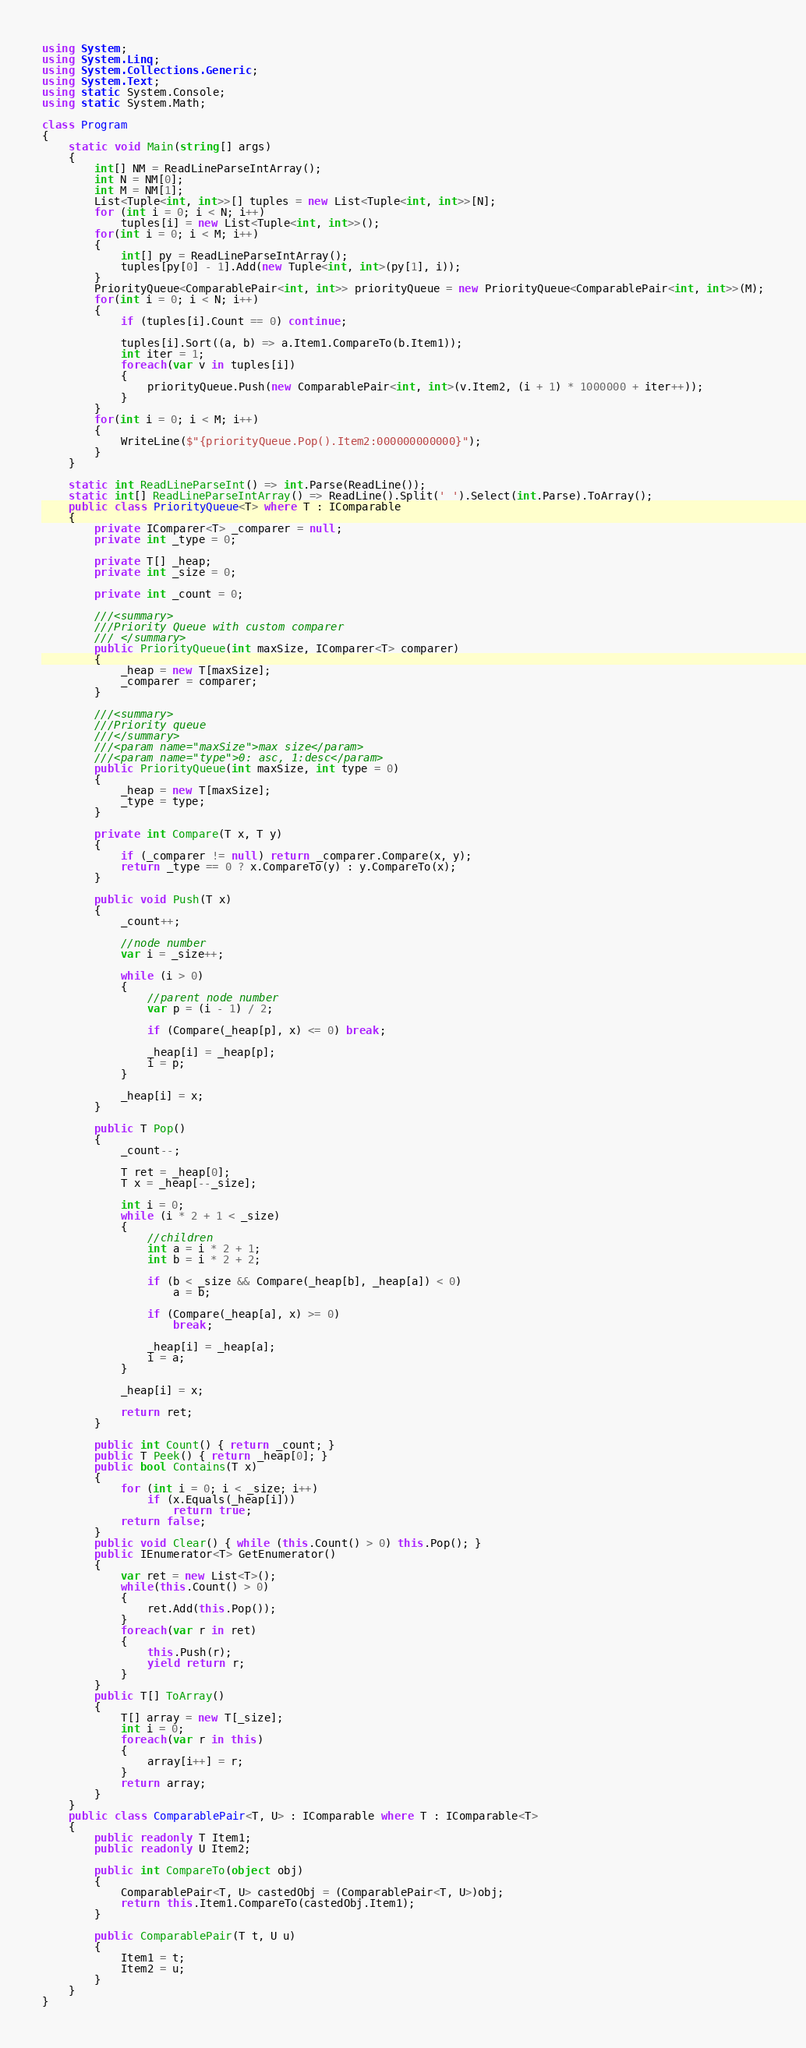<code> <loc_0><loc_0><loc_500><loc_500><_C#_>using System;
using System.Linq;
using System.Collections.Generic;
using System.Text;
using static System.Console;
using static System.Math;

class Program
{
    static void Main(string[] args)
    {
        int[] NM = ReadLineParseIntArray();
        int N = NM[0];
        int M = NM[1];
        List<Tuple<int, int>>[] tuples = new List<Tuple<int, int>>[N];
        for (int i = 0; i < N; i++)
            tuples[i] = new List<Tuple<int, int>>();
        for(int i = 0; i < M; i++)
        {
            int[] py = ReadLineParseIntArray();
            tuples[py[0] - 1].Add(new Tuple<int, int>(py[1], i));
        }
        PriorityQueue<ComparablePair<int, int>> priorityQueue = new PriorityQueue<ComparablePair<int, int>>(M);
        for(int i = 0; i < N; i++)
        {
            if (tuples[i].Count == 0) continue;

            tuples[i].Sort((a, b) => a.Item1.CompareTo(b.Item1));
            int iter = 1;
            foreach(var v in tuples[i])
            {
                priorityQueue.Push(new ComparablePair<int, int>(v.Item2, (i + 1) * 1000000 + iter++));
            }
        }
        for(int i = 0; i < M; i++)
        {
            WriteLine($"{priorityQueue.Pop().Item2:000000000000}");
        }
    }

    static int ReadLineParseInt() => int.Parse(ReadLine());
    static int[] ReadLineParseIntArray() => ReadLine().Split(' ').Select(int.Parse).ToArray();
    public class PriorityQueue<T> where T : IComparable
    {
        private IComparer<T> _comparer = null;
        private int _type = 0;

        private T[] _heap;
        private int _size = 0;

        private int _count = 0;

        ///<summary>
        ///Priority Queue with custom comparer
        /// </summary>
        public PriorityQueue(int maxSize, IComparer<T> comparer)
        {
            _heap = new T[maxSize];
            _comparer = comparer;
        }

        ///<summary>
        ///Priority queue
        ///</summary>
        ///<param name="maxSize">max size</param>
        ///<param name="type">0: asc, 1:desc</param>
        public PriorityQueue(int maxSize, int type = 0)
        {
            _heap = new T[maxSize];
            _type = type;
        }

        private int Compare(T x, T y)
        {
            if (_comparer != null) return _comparer.Compare(x, y);
            return _type == 0 ? x.CompareTo(y) : y.CompareTo(x);
        }

        public void Push(T x)
        {
            _count++;

            //node number
            var i = _size++;

            while (i > 0)
            {
                //parent node number
                var p = (i - 1) / 2;

                if (Compare(_heap[p], x) <= 0) break;

                _heap[i] = _heap[p];
                i = p;
            }

            _heap[i] = x;
        }

        public T Pop()
        {
            _count--;

            T ret = _heap[0];
            T x = _heap[--_size];

            int i = 0;
            while (i * 2 + 1 < _size)
            {
                //children
                int a = i * 2 + 1;
                int b = i * 2 + 2;

                if (b < _size && Compare(_heap[b], _heap[a]) < 0)
                    a = b;

                if (Compare(_heap[a], x) >= 0)
                    break;

                _heap[i] = _heap[a];
                i = a;
            }

            _heap[i] = x;

            return ret;
        }

        public int Count() { return _count; }
        public T Peek() { return _heap[0]; }
        public bool Contains(T x)
        {
            for (int i = 0; i < _size; i++)
                if (x.Equals(_heap[i]))
                    return true;
            return false;
        }
        public void Clear() { while (this.Count() > 0) this.Pop(); }
        public IEnumerator<T> GetEnumerator()
        {
            var ret = new List<T>();
            while(this.Count() > 0)
            {
                ret.Add(this.Pop());
            }
            foreach(var r in ret)
            {
                this.Push(r);
                yield return r;
            }
        }
        public T[] ToArray()
        {
            T[] array = new T[_size];
            int i = 0;
            foreach(var r in this)
            {
                array[i++] = r;
            }
            return array;
        }
    }
    public class ComparablePair<T, U> : IComparable where T : IComparable<T>
    {
        public readonly T Item1;
        public readonly U Item2;

        public int CompareTo(object obj)
        {
            ComparablePair<T, U> castedObj = (ComparablePair<T, U>)obj;
            return this.Item1.CompareTo(castedObj.Item1);
        }

        public ComparablePair(T t, U u)
        {
            Item1 = t;
            Item2 = u;
        }
    }
}</code> 